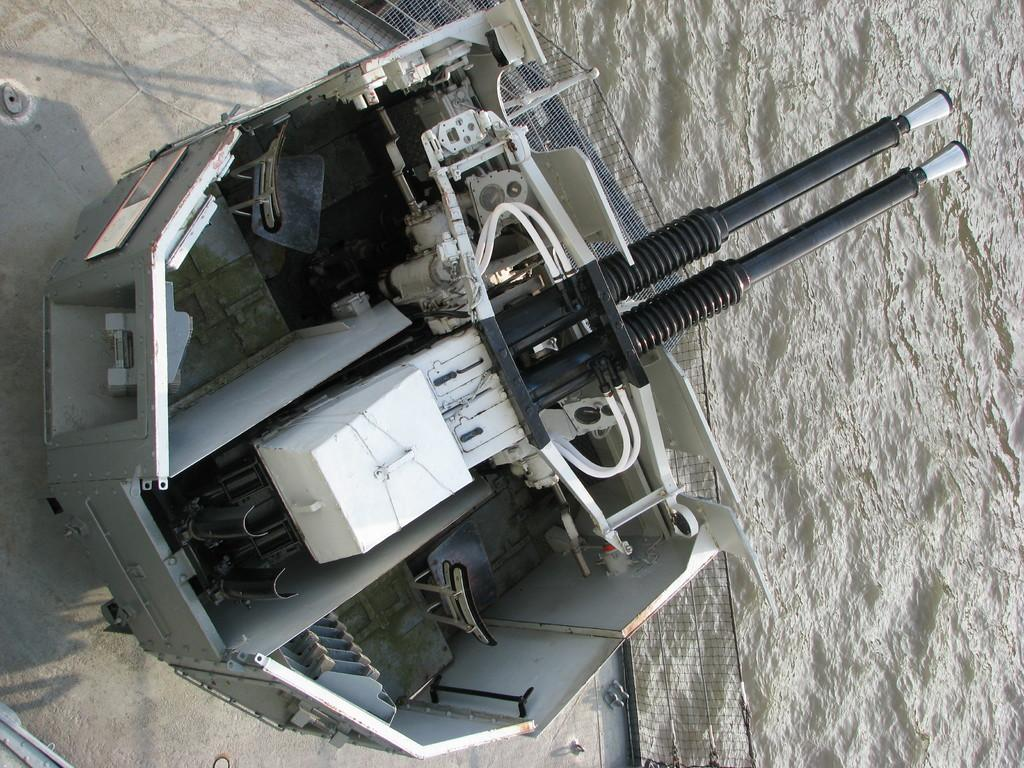What is the main subject of the image? The main subject of the image is a tanker. What is the tanker holding in the image? The tanker has a rifle in the image. Where are the tanker and rifle located in the image? The tanker and rifle are placed in the water in the image. What type of environment can be seen in the image? There is water visible in the image, which might be in a river. What type of reward is the tanker receiving from the bushes in the image? There are no bushes or rewards present in the image; it only features a tanker with a rifle in the water. 